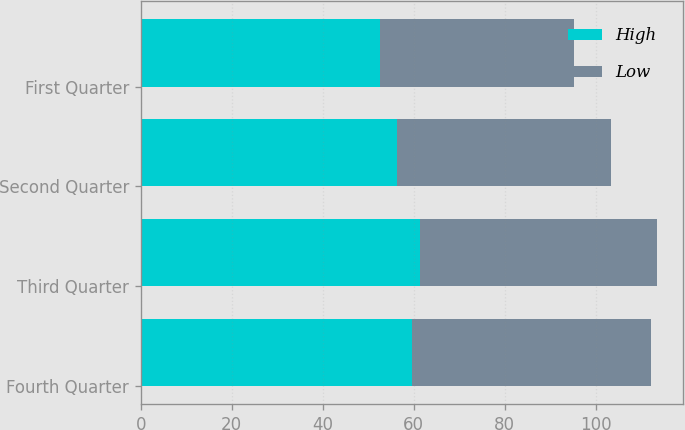Convert chart to OTSL. <chart><loc_0><loc_0><loc_500><loc_500><stacked_bar_chart><ecel><fcel>Fourth Quarter<fcel>Third Quarter<fcel>Second Quarter<fcel>First Quarter<nl><fcel>High<fcel>59.66<fcel>61.48<fcel>56.29<fcel>52.5<nl><fcel>Low<fcel>52.36<fcel>51.99<fcel>46.96<fcel>42.64<nl></chart> 